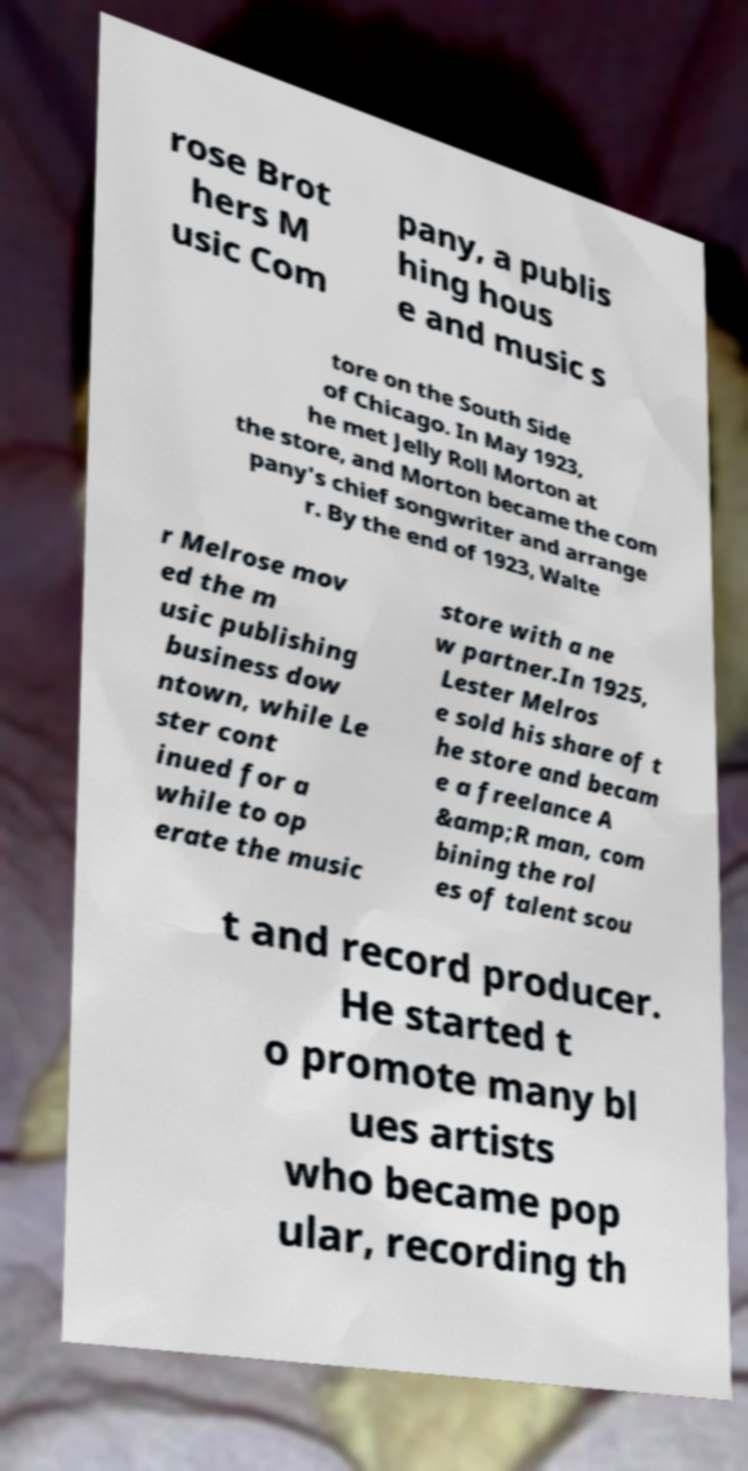Please read and relay the text visible in this image. What does it say? rose Brot hers M usic Com pany, a publis hing hous e and music s tore on the South Side of Chicago. In May 1923, he met Jelly Roll Morton at the store, and Morton became the com pany's chief songwriter and arrange r. By the end of 1923, Walte r Melrose mov ed the m usic publishing business dow ntown, while Le ster cont inued for a while to op erate the music store with a ne w partner.In 1925, Lester Melros e sold his share of t he store and becam e a freelance A &amp;R man, com bining the rol es of talent scou t and record producer. He started t o promote many bl ues artists who became pop ular, recording th 